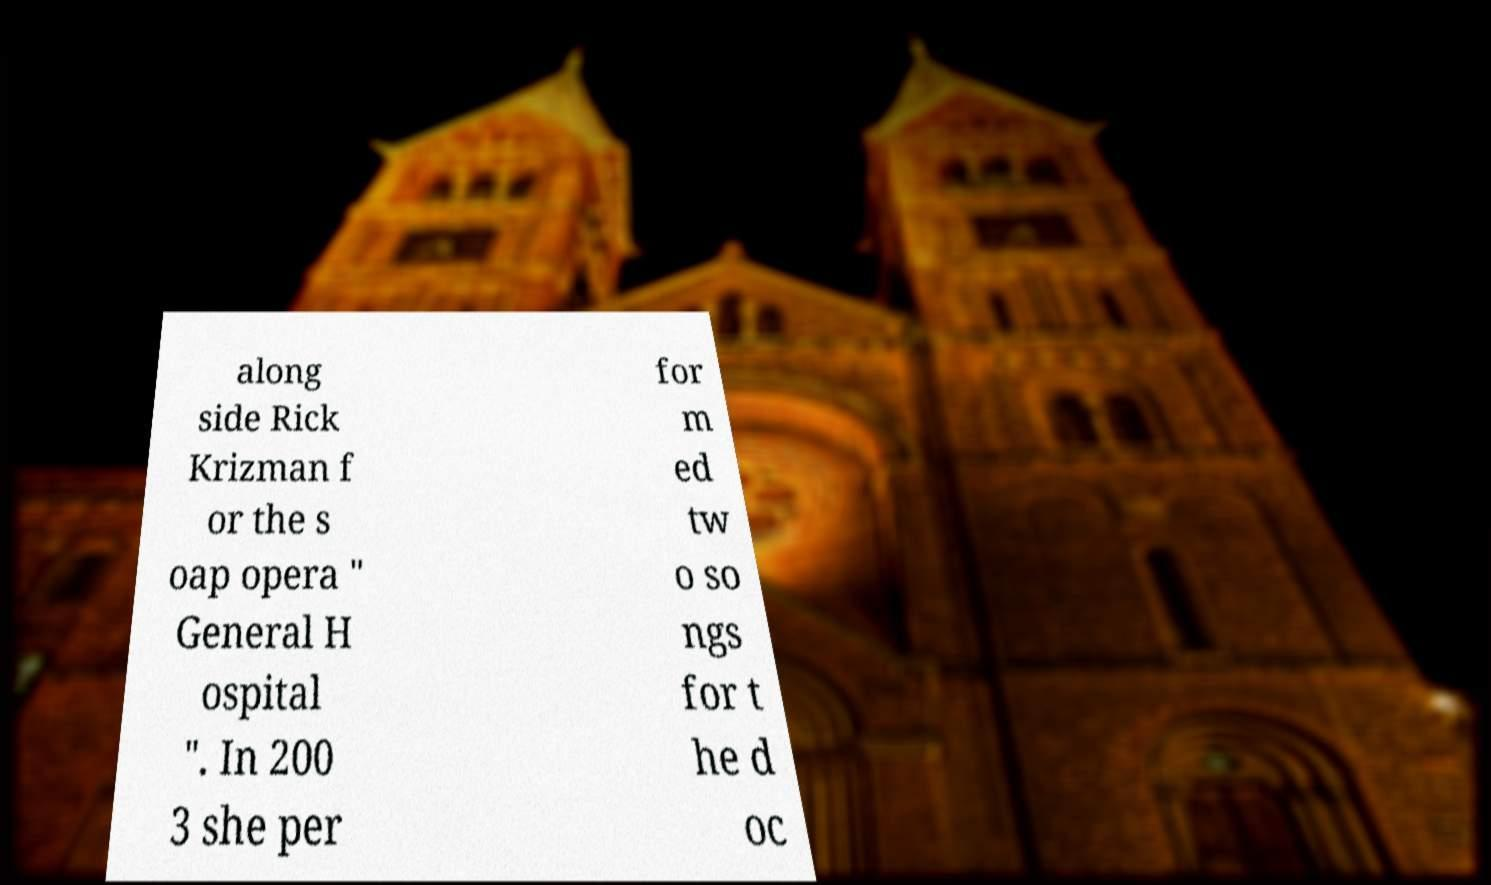Can you accurately transcribe the text from the provided image for me? along side Rick Krizman f or the s oap opera " General H ospital ". In 200 3 she per for m ed tw o so ngs for t he d oc 